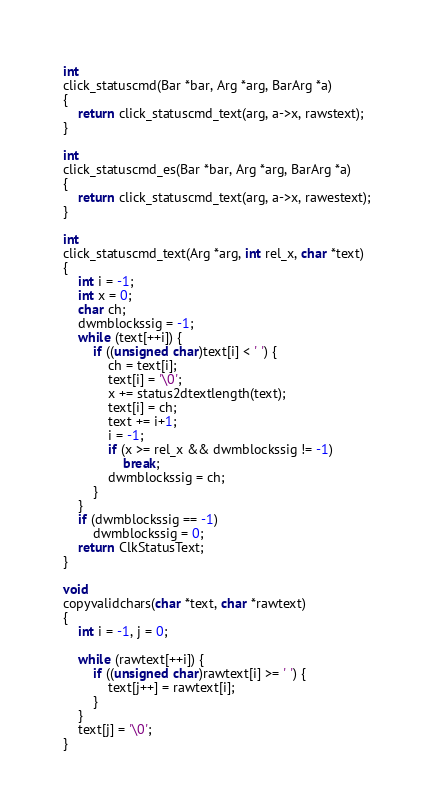<code> <loc_0><loc_0><loc_500><loc_500><_C_>int
click_statuscmd(Bar *bar, Arg *arg, BarArg *a)
{
	return click_statuscmd_text(arg, a->x, rawstext);
}

int
click_statuscmd_es(Bar *bar, Arg *arg, BarArg *a)
{
	return click_statuscmd_text(arg, a->x, rawestext);
}

int
click_statuscmd_text(Arg *arg, int rel_x, char *text)
{
	int i = -1;
	int x = 0;
	char ch;
	dwmblockssig = -1;
	while (text[++i]) {
		if ((unsigned char)text[i] < ' ') {
			ch = text[i];
			text[i] = '\0';
			x += status2dtextlength(text);
			text[i] = ch;
			text += i+1;
			i = -1;
			if (x >= rel_x && dwmblockssig != -1)
				break;
			dwmblockssig = ch;
		}
	}
	if (dwmblockssig == -1)
		dwmblockssig = 0;
	return ClkStatusText;
}

void
copyvalidchars(char *text, char *rawtext)
{
	int i = -1, j = 0;

	while (rawtext[++i]) {
		if ((unsigned char)rawtext[i] >= ' ') {
			text[j++] = rawtext[i];
		}
	}
	text[j] = '\0';
}
</code> 